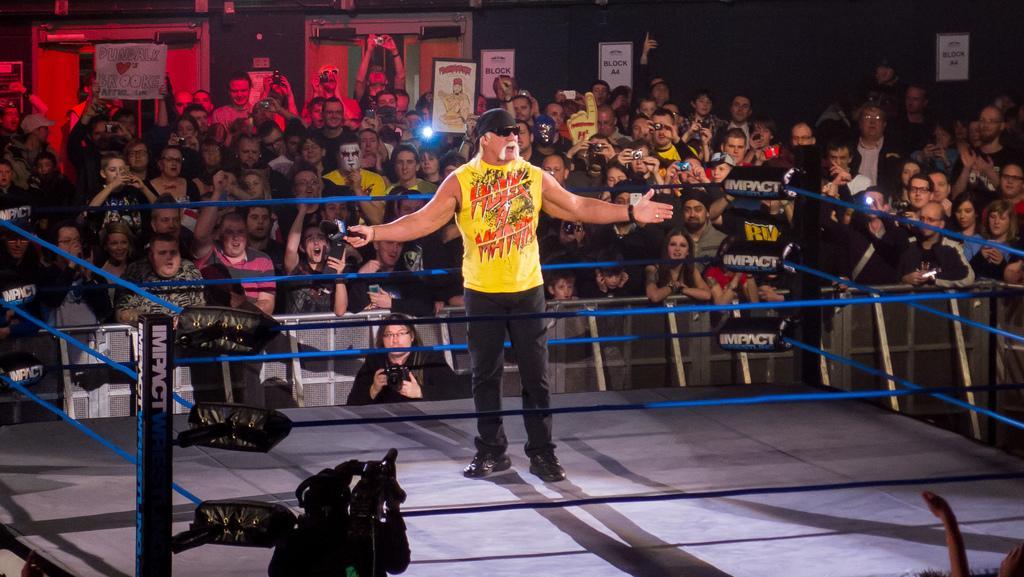Describe this image in one or two sentences. In the foreground of this picture, there is a man holding a mic and standing on a boxing court. On the bottom, there is a man holding camera. In the background, there is a crowd holding pluck-cards, and the doors. 